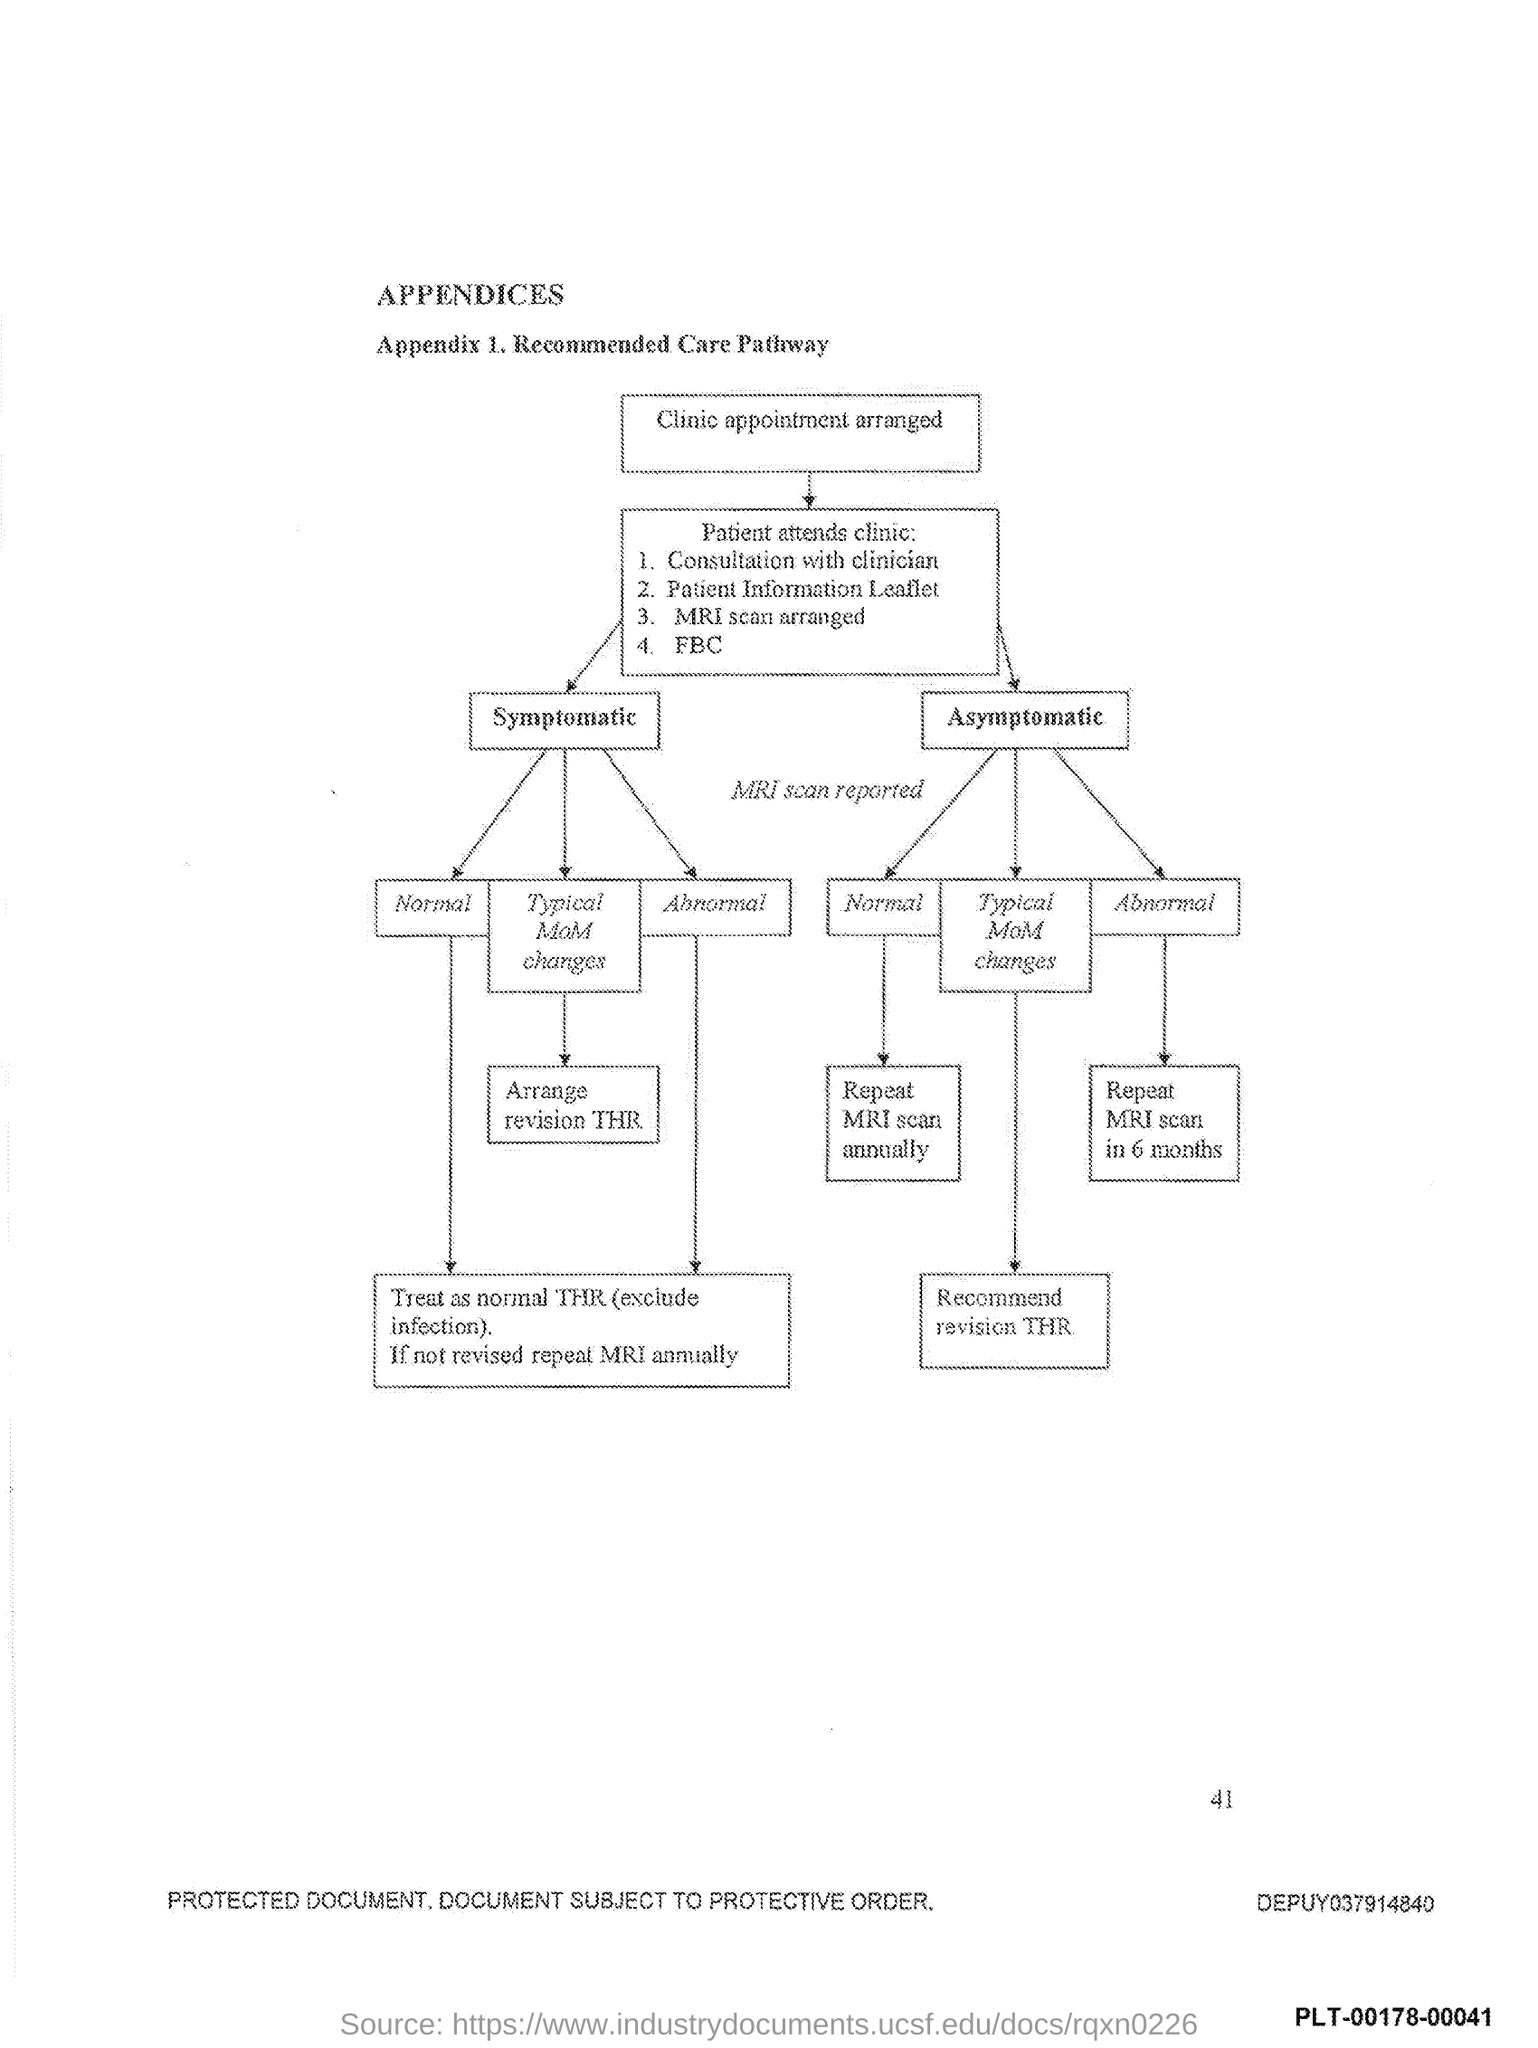Draw attention to some important aspects in this diagram. The number at the bottom right side of the page is 41. 